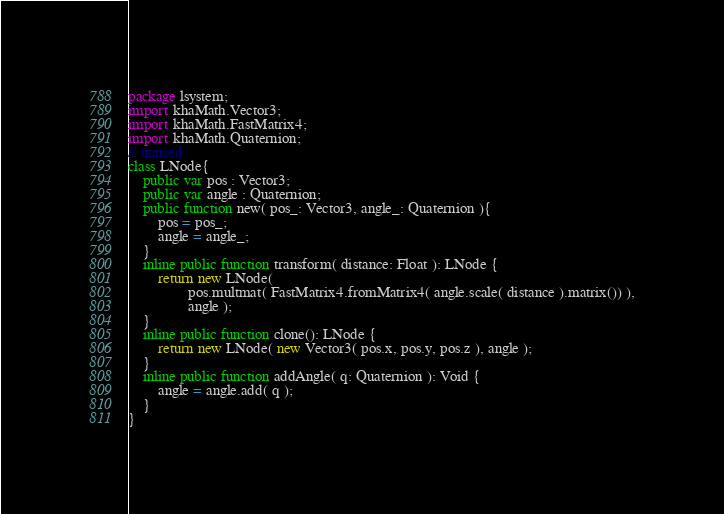Convert code to text. <code><loc_0><loc_0><loc_500><loc_500><_Haxe_>package lsystem;
import khaMath.Vector3;
import khaMath.FastMatrix4;
import khaMath.Quaternion;
// unused.
class LNode{
    public var pos : Vector3;
    public var angle : Quaternion;
    public function new( pos_: Vector3, angle_: Quaternion ){
        pos = pos_;
        angle = angle_;
    }
    inline public function transform( distance: Float ): LNode {
        return new LNode( 
                pos.multmat( FastMatrix4.fromMatrix4( angle.scale( distance ).matrix()) ),
                angle );
    }
    inline public function clone(): LNode {
        return new LNode( new Vector3( pos.x, pos.y, pos.z ), angle );
    }
    inline public function addAngle( q: Quaternion ): Void {
        angle = angle.add( q );
    }
}
</code> 